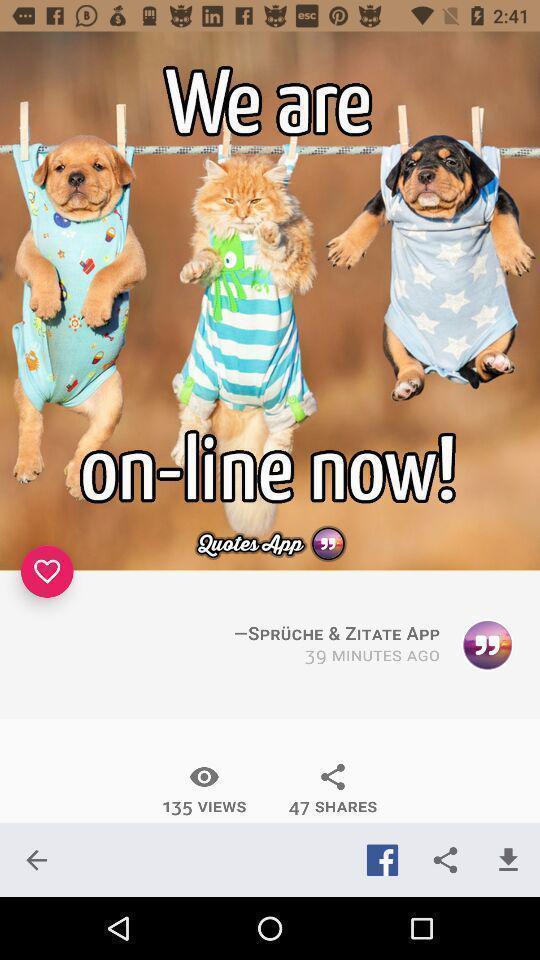Provide a textual representation of this image. Welcome page of quotes application. 